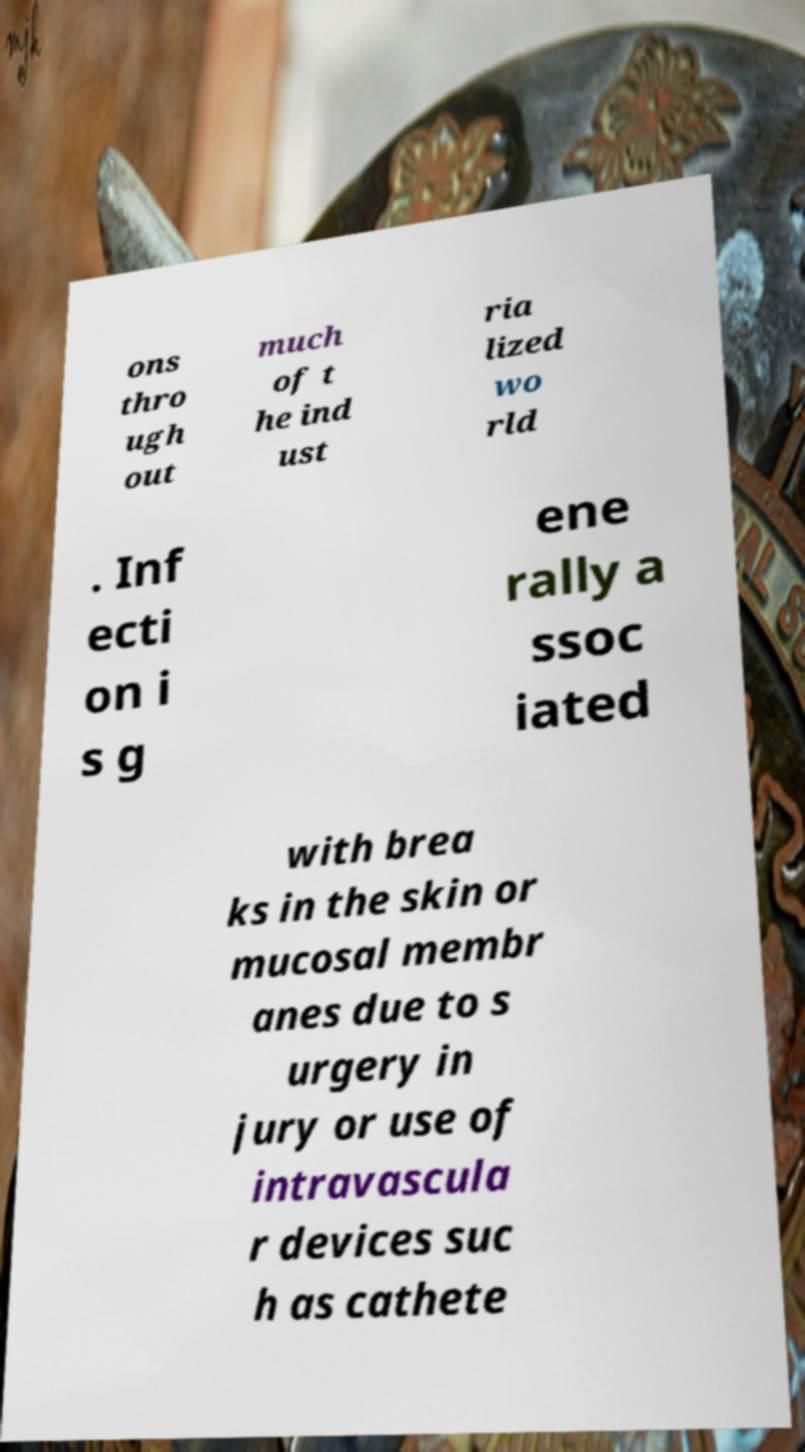Could you assist in decoding the text presented in this image and type it out clearly? ons thro ugh out much of t he ind ust ria lized wo rld . Inf ecti on i s g ene rally a ssoc iated with brea ks in the skin or mucosal membr anes due to s urgery in jury or use of intravascula r devices suc h as cathete 